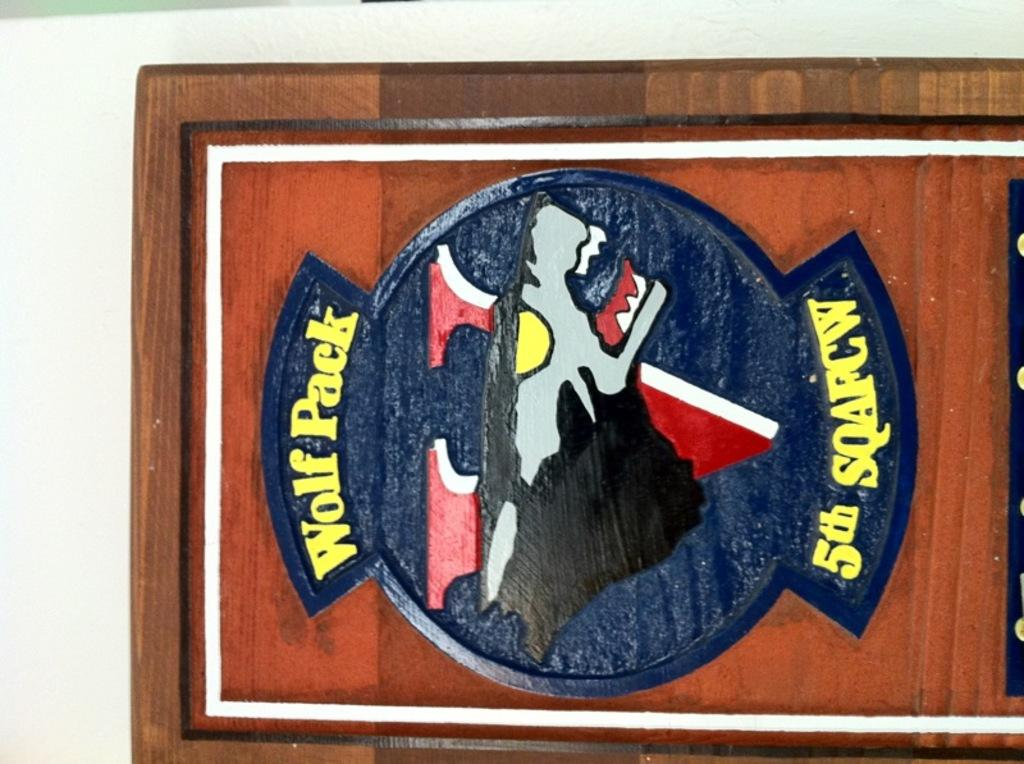<image>
Present a compact description of the photo's key features. a plaque reading Wolf Pack 5th Squafcw on a white wall 